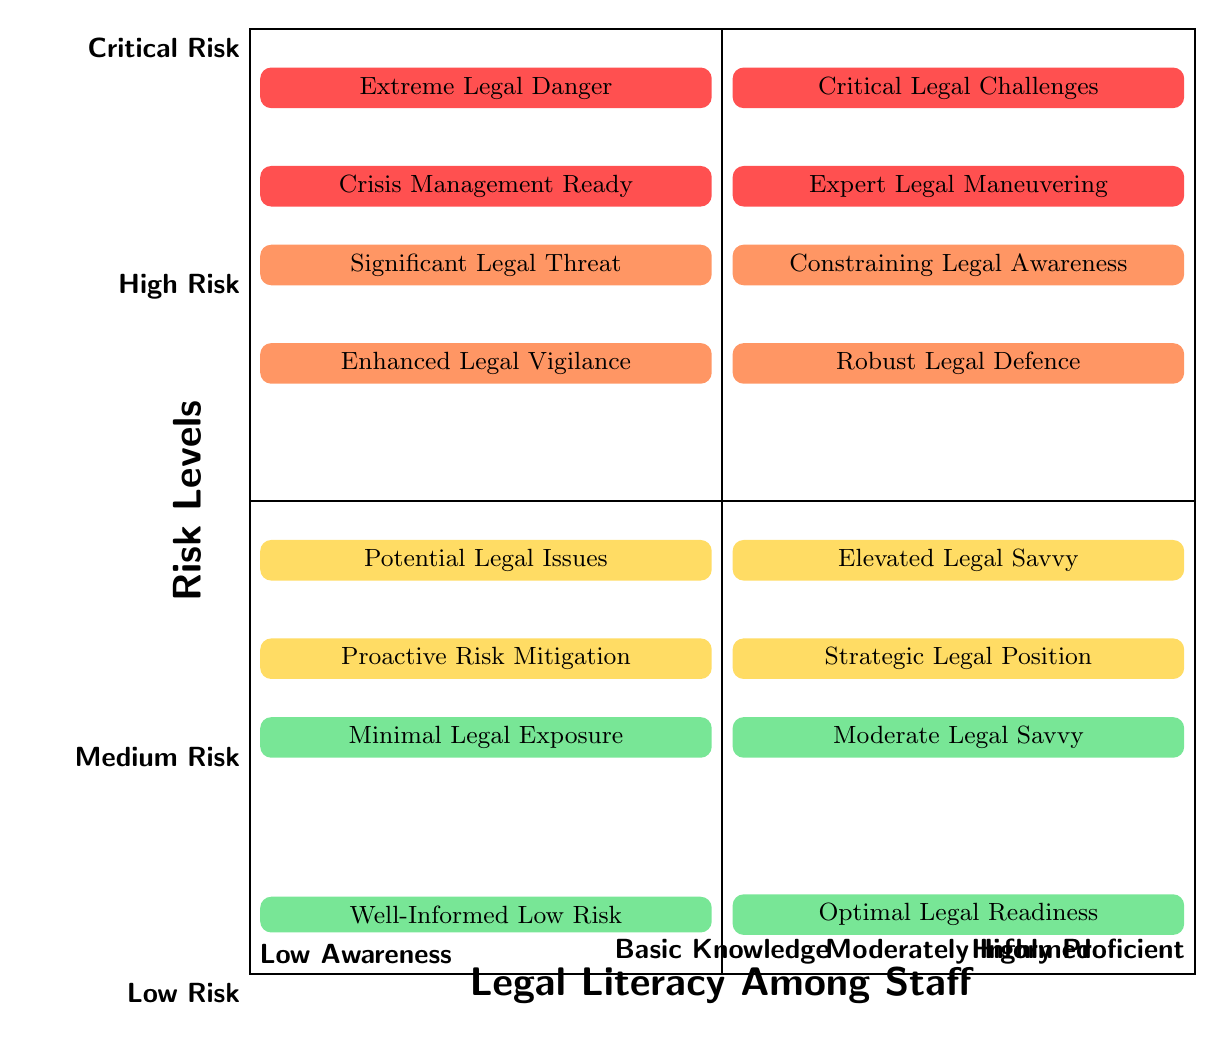What is the label for the "High Risk" and "Low Awareness" quadrant? The label for this quadrant is located in the upper left section of the quadrant chart. It corresponds to "High Risk" on the vertical axis and "Low Awareness" on the horizontal axis. The label for this section states "Significant Legal Threat".
Answer: Significant Legal Threat How many total quadrants are represented in the chart? The chart is divided into four quadrants, categorized by risk levels (Low, Medium, High, Critical) on the vertical axis and by legal literacy levels (Low Awareness, Basic Knowledge, Moderately Informed, Highly Proficient) on the horizontal axis. The total number of quadrants is four.
Answer: Four What does the "Medium Risk" and "Basic Knowledge" quadrant imply? Located in the second row from the bottom and second column from the left, this quadrant indicates an elevated understanding of law among staff members situated in a medium risk environment. The label "Elevated Legal Savvy" suggests that employees have an increased awareness of legal matters, reducing potential risks.
Answer: Elevated Legal Savvy Which quadrant indicates "Crisis Management Ready"? To find this, we reference the leftmost column where "Critical Risk" is indicated and then move right to the second column. The label for this quadrant confirms it as "Crisis Management Ready".
Answer: Crisis Management Ready Explain the relationship between "Low Risk" and "Highly Proficient" levels The lowest row represents "Low Risk", while the farthest right column represents "Highly Proficient". The intersection of these two categories leads to the label "Optimal Legal Readiness", indicating that staff members are at low risk while also being highly proficient in legal understanding, minimizing exposure to legal issues.
Answer: Optimal Legal Readiness In which quadrant would you find "Extreme Legal Danger"? This label is located at the top left quadrant of the chart, where "Critical Risk" and "Low Awareness" intersect. The chart clearly labels that specific section as "Extreme Legal Danger".
Answer: Extreme Legal Danger What is the label in the quadrant for "High Risk" and "Moderately Informed"? This quadrant is found in the third row from the top and the third column from the left. It emphasizes a heightened legal situation. The respective label for this quadrant is "Enhanced Legal Vigilance".
Answer: Enhanced Legal Vigilance How many labels indicate favorable legal conditions? To determine this, we identify the labels in the left half of the chart where legal savvy is present but of low or medium risk. The labels "Optimal Legal Readiness", "Proactive Risk Mitigation", and "Strategic Legal Position" are three indicators of favorable conditions.
Answer: Three 